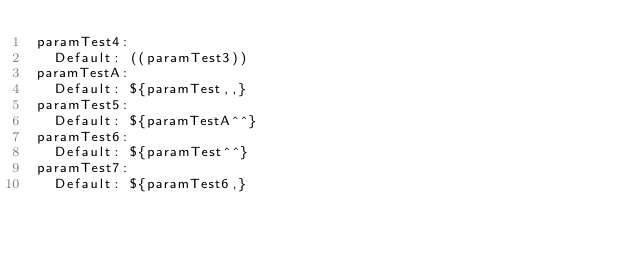<code> <loc_0><loc_0><loc_500><loc_500><_YAML_>paramTest4:
  Default: ((paramTest3))
paramTestA:
  Default: ${paramTest,,}
paramTest5:
  Default: ${paramTestA^^}
paramTest6:
  Default: ${paramTest^^}
paramTest7:
  Default: ${paramTest6,}</code> 